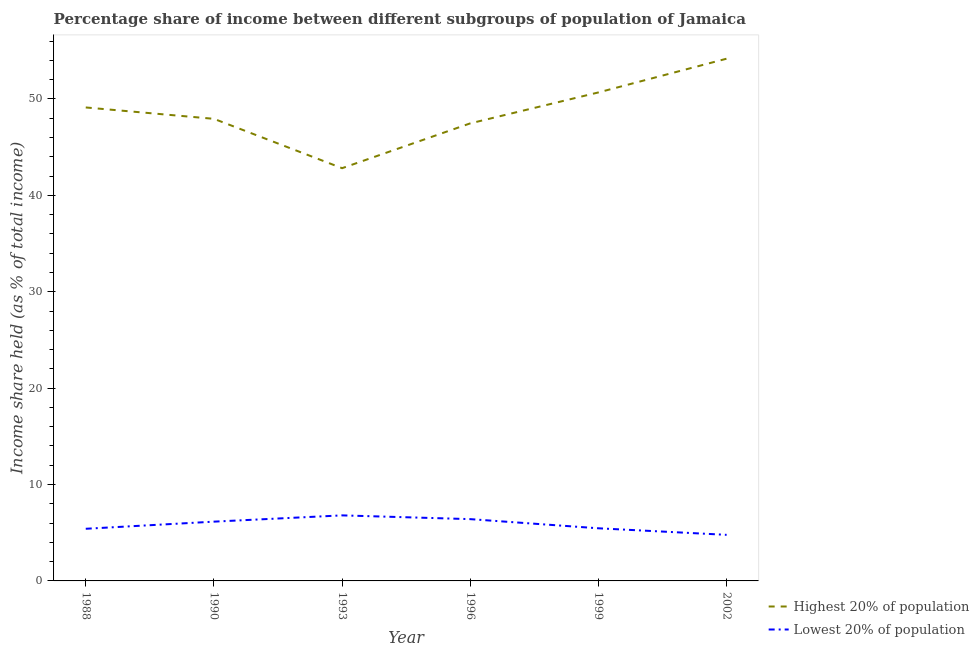How many different coloured lines are there?
Keep it short and to the point. 2. Does the line corresponding to income share held by lowest 20% of the population intersect with the line corresponding to income share held by highest 20% of the population?
Provide a succinct answer. No. Is the number of lines equal to the number of legend labels?
Ensure brevity in your answer.  Yes. What is the income share held by highest 20% of the population in 1999?
Your answer should be very brief. 50.68. Across all years, what is the maximum income share held by highest 20% of the population?
Offer a very short reply. 54.18. Across all years, what is the minimum income share held by lowest 20% of the population?
Offer a very short reply. 4.78. In which year was the income share held by lowest 20% of the population maximum?
Offer a very short reply. 1993. What is the total income share held by highest 20% of the population in the graph?
Your response must be concise. 292.21. What is the difference between the income share held by highest 20% of the population in 1988 and that in 1999?
Make the answer very short. -1.56. What is the difference between the income share held by highest 20% of the population in 1996 and the income share held by lowest 20% of the population in 1993?
Provide a succinct answer. 40.67. What is the average income share held by lowest 20% of the population per year?
Your response must be concise. 5.83. In the year 1993, what is the difference between the income share held by lowest 20% of the population and income share held by highest 20% of the population?
Provide a short and direct response. -36.02. In how many years, is the income share held by lowest 20% of the population greater than 42 %?
Offer a terse response. 0. What is the ratio of the income share held by lowest 20% of the population in 1999 to that in 2002?
Offer a very short reply. 1.14. What is the difference between the highest and the second highest income share held by lowest 20% of the population?
Offer a very short reply. 0.39. What is the difference between the highest and the lowest income share held by highest 20% of the population?
Provide a succinct answer. 11.36. In how many years, is the income share held by lowest 20% of the population greater than the average income share held by lowest 20% of the population taken over all years?
Give a very brief answer. 3. Is the sum of the income share held by lowest 20% of the population in 1988 and 1990 greater than the maximum income share held by highest 20% of the population across all years?
Give a very brief answer. No. Does the income share held by highest 20% of the population monotonically increase over the years?
Provide a succinct answer. No. Is the income share held by highest 20% of the population strictly greater than the income share held by lowest 20% of the population over the years?
Offer a terse response. Yes. Is the income share held by lowest 20% of the population strictly less than the income share held by highest 20% of the population over the years?
Provide a succinct answer. Yes. How many years are there in the graph?
Your answer should be compact. 6. Where does the legend appear in the graph?
Your answer should be compact. Bottom right. How many legend labels are there?
Provide a succinct answer. 2. What is the title of the graph?
Offer a terse response. Percentage share of income between different subgroups of population of Jamaica. What is the label or title of the X-axis?
Provide a succinct answer. Year. What is the label or title of the Y-axis?
Make the answer very short. Income share held (as % of total income). What is the Income share held (as % of total income) of Highest 20% of population in 1988?
Offer a very short reply. 49.12. What is the Income share held (as % of total income) of Lowest 20% of population in 1988?
Your answer should be compact. 5.41. What is the Income share held (as % of total income) of Highest 20% of population in 1990?
Provide a succinct answer. 47.94. What is the Income share held (as % of total income) of Lowest 20% of population in 1990?
Provide a short and direct response. 6.15. What is the Income share held (as % of total income) of Highest 20% of population in 1993?
Provide a short and direct response. 42.82. What is the Income share held (as % of total income) of Lowest 20% of population in 1993?
Ensure brevity in your answer.  6.8. What is the Income share held (as % of total income) in Highest 20% of population in 1996?
Your response must be concise. 47.47. What is the Income share held (as % of total income) in Lowest 20% of population in 1996?
Keep it short and to the point. 6.41. What is the Income share held (as % of total income) in Highest 20% of population in 1999?
Your response must be concise. 50.68. What is the Income share held (as % of total income) of Lowest 20% of population in 1999?
Keep it short and to the point. 5.46. What is the Income share held (as % of total income) in Highest 20% of population in 2002?
Give a very brief answer. 54.18. What is the Income share held (as % of total income) in Lowest 20% of population in 2002?
Offer a very short reply. 4.78. Across all years, what is the maximum Income share held (as % of total income) in Highest 20% of population?
Offer a terse response. 54.18. Across all years, what is the maximum Income share held (as % of total income) in Lowest 20% of population?
Provide a short and direct response. 6.8. Across all years, what is the minimum Income share held (as % of total income) of Highest 20% of population?
Make the answer very short. 42.82. Across all years, what is the minimum Income share held (as % of total income) of Lowest 20% of population?
Provide a succinct answer. 4.78. What is the total Income share held (as % of total income) in Highest 20% of population in the graph?
Provide a succinct answer. 292.21. What is the total Income share held (as % of total income) in Lowest 20% of population in the graph?
Keep it short and to the point. 35.01. What is the difference between the Income share held (as % of total income) of Highest 20% of population in 1988 and that in 1990?
Your response must be concise. 1.18. What is the difference between the Income share held (as % of total income) of Lowest 20% of population in 1988 and that in 1990?
Keep it short and to the point. -0.74. What is the difference between the Income share held (as % of total income) of Lowest 20% of population in 1988 and that in 1993?
Keep it short and to the point. -1.39. What is the difference between the Income share held (as % of total income) of Highest 20% of population in 1988 and that in 1996?
Your answer should be very brief. 1.65. What is the difference between the Income share held (as % of total income) in Lowest 20% of population in 1988 and that in 1996?
Ensure brevity in your answer.  -1. What is the difference between the Income share held (as % of total income) of Highest 20% of population in 1988 and that in 1999?
Offer a terse response. -1.56. What is the difference between the Income share held (as % of total income) in Highest 20% of population in 1988 and that in 2002?
Offer a terse response. -5.06. What is the difference between the Income share held (as % of total income) in Lowest 20% of population in 1988 and that in 2002?
Provide a succinct answer. 0.63. What is the difference between the Income share held (as % of total income) in Highest 20% of population in 1990 and that in 1993?
Provide a succinct answer. 5.12. What is the difference between the Income share held (as % of total income) of Lowest 20% of population in 1990 and that in 1993?
Offer a terse response. -0.65. What is the difference between the Income share held (as % of total income) in Highest 20% of population in 1990 and that in 1996?
Offer a very short reply. 0.47. What is the difference between the Income share held (as % of total income) in Lowest 20% of population in 1990 and that in 1996?
Provide a succinct answer. -0.26. What is the difference between the Income share held (as % of total income) in Highest 20% of population in 1990 and that in 1999?
Your response must be concise. -2.74. What is the difference between the Income share held (as % of total income) of Lowest 20% of population in 1990 and that in 1999?
Make the answer very short. 0.69. What is the difference between the Income share held (as % of total income) in Highest 20% of population in 1990 and that in 2002?
Ensure brevity in your answer.  -6.24. What is the difference between the Income share held (as % of total income) of Lowest 20% of population in 1990 and that in 2002?
Provide a succinct answer. 1.37. What is the difference between the Income share held (as % of total income) in Highest 20% of population in 1993 and that in 1996?
Ensure brevity in your answer.  -4.65. What is the difference between the Income share held (as % of total income) in Lowest 20% of population in 1993 and that in 1996?
Offer a very short reply. 0.39. What is the difference between the Income share held (as % of total income) in Highest 20% of population in 1993 and that in 1999?
Provide a succinct answer. -7.86. What is the difference between the Income share held (as % of total income) in Lowest 20% of population in 1993 and that in 1999?
Offer a very short reply. 1.34. What is the difference between the Income share held (as % of total income) of Highest 20% of population in 1993 and that in 2002?
Provide a succinct answer. -11.36. What is the difference between the Income share held (as % of total income) of Lowest 20% of population in 1993 and that in 2002?
Provide a succinct answer. 2.02. What is the difference between the Income share held (as % of total income) of Highest 20% of population in 1996 and that in 1999?
Provide a short and direct response. -3.21. What is the difference between the Income share held (as % of total income) of Lowest 20% of population in 1996 and that in 1999?
Your answer should be compact. 0.95. What is the difference between the Income share held (as % of total income) in Highest 20% of population in 1996 and that in 2002?
Provide a succinct answer. -6.71. What is the difference between the Income share held (as % of total income) of Lowest 20% of population in 1996 and that in 2002?
Your response must be concise. 1.63. What is the difference between the Income share held (as % of total income) in Highest 20% of population in 1999 and that in 2002?
Offer a very short reply. -3.5. What is the difference between the Income share held (as % of total income) in Lowest 20% of population in 1999 and that in 2002?
Offer a very short reply. 0.68. What is the difference between the Income share held (as % of total income) of Highest 20% of population in 1988 and the Income share held (as % of total income) of Lowest 20% of population in 1990?
Give a very brief answer. 42.97. What is the difference between the Income share held (as % of total income) in Highest 20% of population in 1988 and the Income share held (as % of total income) in Lowest 20% of population in 1993?
Ensure brevity in your answer.  42.32. What is the difference between the Income share held (as % of total income) of Highest 20% of population in 1988 and the Income share held (as % of total income) of Lowest 20% of population in 1996?
Your answer should be very brief. 42.71. What is the difference between the Income share held (as % of total income) of Highest 20% of population in 1988 and the Income share held (as % of total income) of Lowest 20% of population in 1999?
Ensure brevity in your answer.  43.66. What is the difference between the Income share held (as % of total income) in Highest 20% of population in 1988 and the Income share held (as % of total income) in Lowest 20% of population in 2002?
Your answer should be very brief. 44.34. What is the difference between the Income share held (as % of total income) in Highest 20% of population in 1990 and the Income share held (as % of total income) in Lowest 20% of population in 1993?
Provide a short and direct response. 41.14. What is the difference between the Income share held (as % of total income) of Highest 20% of population in 1990 and the Income share held (as % of total income) of Lowest 20% of population in 1996?
Provide a short and direct response. 41.53. What is the difference between the Income share held (as % of total income) of Highest 20% of population in 1990 and the Income share held (as % of total income) of Lowest 20% of population in 1999?
Offer a terse response. 42.48. What is the difference between the Income share held (as % of total income) of Highest 20% of population in 1990 and the Income share held (as % of total income) of Lowest 20% of population in 2002?
Provide a short and direct response. 43.16. What is the difference between the Income share held (as % of total income) in Highest 20% of population in 1993 and the Income share held (as % of total income) in Lowest 20% of population in 1996?
Offer a terse response. 36.41. What is the difference between the Income share held (as % of total income) in Highest 20% of population in 1993 and the Income share held (as % of total income) in Lowest 20% of population in 1999?
Offer a very short reply. 37.36. What is the difference between the Income share held (as % of total income) in Highest 20% of population in 1993 and the Income share held (as % of total income) in Lowest 20% of population in 2002?
Keep it short and to the point. 38.04. What is the difference between the Income share held (as % of total income) of Highest 20% of population in 1996 and the Income share held (as % of total income) of Lowest 20% of population in 1999?
Provide a short and direct response. 42.01. What is the difference between the Income share held (as % of total income) of Highest 20% of population in 1996 and the Income share held (as % of total income) of Lowest 20% of population in 2002?
Ensure brevity in your answer.  42.69. What is the difference between the Income share held (as % of total income) in Highest 20% of population in 1999 and the Income share held (as % of total income) in Lowest 20% of population in 2002?
Your response must be concise. 45.9. What is the average Income share held (as % of total income) in Highest 20% of population per year?
Provide a succinct answer. 48.7. What is the average Income share held (as % of total income) of Lowest 20% of population per year?
Provide a succinct answer. 5.83. In the year 1988, what is the difference between the Income share held (as % of total income) of Highest 20% of population and Income share held (as % of total income) of Lowest 20% of population?
Keep it short and to the point. 43.71. In the year 1990, what is the difference between the Income share held (as % of total income) in Highest 20% of population and Income share held (as % of total income) in Lowest 20% of population?
Give a very brief answer. 41.79. In the year 1993, what is the difference between the Income share held (as % of total income) in Highest 20% of population and Income share held (as % of total income) in Lowest 20% of population?
Your answer should be compact. 36.02. In the year 1996, what is the difference between the Income share held (as % of total income) of Highest 20% of population and Income share held (as % of total income) of Lowest 20% of population?
Your answer should be compact. 41.06. In the year 1999, what is the difference between the Income share held (as % of total income) of Highest 20% of population and Income share held (as % of total income) of Lowest 20% of population?
Keep it short and to the point. 45.22. In the year 2002, what is the difference between the Income share held (as % of total income) of Highest 20% of population and Income share held (as % of total income) of Lowest 20% of population?
Provide a succinct answer. 49.4. What is the ratio of the Income share held (as % of total income) of Highest 20% of population in 1988 to that in 1990?
Provide a succinct answer. 1.02. What is the ratio of the Income share held (as % of total income) in Lowest 20% of population in 1988 to that in 1990?
Keep it short and to the point. 0.88. What is the ratio of the Income share held (as % of total income) in Highest 20% of population in 1988 to that in 1993?
Give a very brief answer. 1.15. What is the ratio of the Income share held (as % of total income) in Lowest 20% of population in 1988 to that in 1993?
Provide a succinct answer. 0.8. What is the ratio of the Income share held (as % of total income) of Highest 20% of population in 1988 to that in 1996?
Provide a short and direct response. 1.03. What is the ratio of the Income share held (as % of total income) of Lowest 20% of population in 1988 to that in 1996?
Offer a terse response. 0.84. What is the ratio of the Income share held (as % of total income) of Highest 20% of population in 1988 to that in 1999?
Provide a succinct answer. 0.97. What is the ratio of the Income share held (as % of total income) of Highest 20% of population in 1988 to that in 2002?
Provide a succinct answer. 0.91. What is the ratio of the Income share held (as % of total income) in Lowest 20% of population in 1988 to that in 2002?
Your response must be concise. 1.13. What is the ratio of the Income share held (as % of total income) in Highest 20% of population in 1990 to that in 1993?
Make the answer very short. 1.12. What is the ratio of the Income share held (as % of total income) of Lowest 20% of population in 1990 to that in 1993?
Keep it short and to the point. 0.9. What is the ratio of the Income share held (as % of total income) in Highest 20% of population in 1990 to that in 1996?
Your answer should be very brief. 1.01. What is the ratio of the Income share held (as % of total income) in Lowest 20% of population in 1990 to that in 1996?
Offer a terse response. 0.96. What is the ratio of the Income share held (as % of total income) in Highest 20% of population in 1990 to that in 1999?
Your answer should be very brief. 0.95. What is the ratio of the Income share held (as % of total income) in Lowest 20% of population in 1990 to that in 1999?
Keep it short and to the point. 1.13. What is the ratio of the Income share held (as % of total income) in Highest 20% of population in 1990 to that in 2002?
Give a very brief answer. 0.88. What is the ratio of the Income share held (as % of total income) of Lowest 20% of population in 1990 to that in 2002?
Make the answer very short. 1.29. What is the ratio of the Income share held (as % of total income) of Highest 20% of population in 1993 to that in 1996?
Your answer should be very brief. 0.9. What is the ratio of the Income share held (as % of total income) of Lowest 20% of population in 1993 to that in 1996?
Give a very brief answer. 1.06. What is the ratio of the Income share held (as % of total income) in Highest 20% of population in 1993 to that in 1999?
Provide a short and direct response. 0.84. What is the ratio of the Income share held (as % of total income) of Lowest 20% of population in 1993 to that in 1999?
Make the answer very short. 1.25. What is the ratio of the Income share held (as % of total income) of Highest 20% of population in 1993 to that in 2002?
Ensure brevity in your answer.  0.79. What is the ratio of the Income share held (as % of total income) of Lowest 20% of population in 1993 to that in 2002?
Make the answer very short. 1.42. What is the ratio of the Income share held (as % of total income) in Highest 20% of population in 1996 to that in 1999?
Keep it short and to the point. 0.94. What is the ratio of the Income share held (as % of total income) of Lowest 20% of population in 1996 to that in 1999?
Give a very brief answer. 1.17. What is the ratio of the Income share held (as % of total income) of Highest 20% of population in 1996 to that in 2002?
Provide a succinct answer. 0.88. What is the ratio of the Income share held (as % of total income) of Lowest 20% of population in 1996 to that in 2002?
Make the answer very short. 1.34. What is the ratio of the Income share held (as % of total income) of Highest 20% of population in 1999 to that in 2002?
Give a very brief answer. 0.94. What is the ratio of the Income share held (as % of total income) in Lowest 20% of population in 1999 to that in 2002?
Ensure brevity in your answer.  1.14. What is the difference between the highest and the second highest Income share held (as % of total income) in Highest 20% of population?
Provide a succinct answer. 3.5. What is the difference between the highest and the second highest Income share held (as % of total income) of Lowest 20% of population?
Offer a very short reply. 0.39. What is the difference between the highest and the lowest Income share held (as % of total income) of Highest 20% of population?
Make the answer very short. 11.36. What is the difference between the highest and the lowest Income share held (as % of total income) in Lowest 20% of population?
Ensure brevity in your answer.  2.02. 